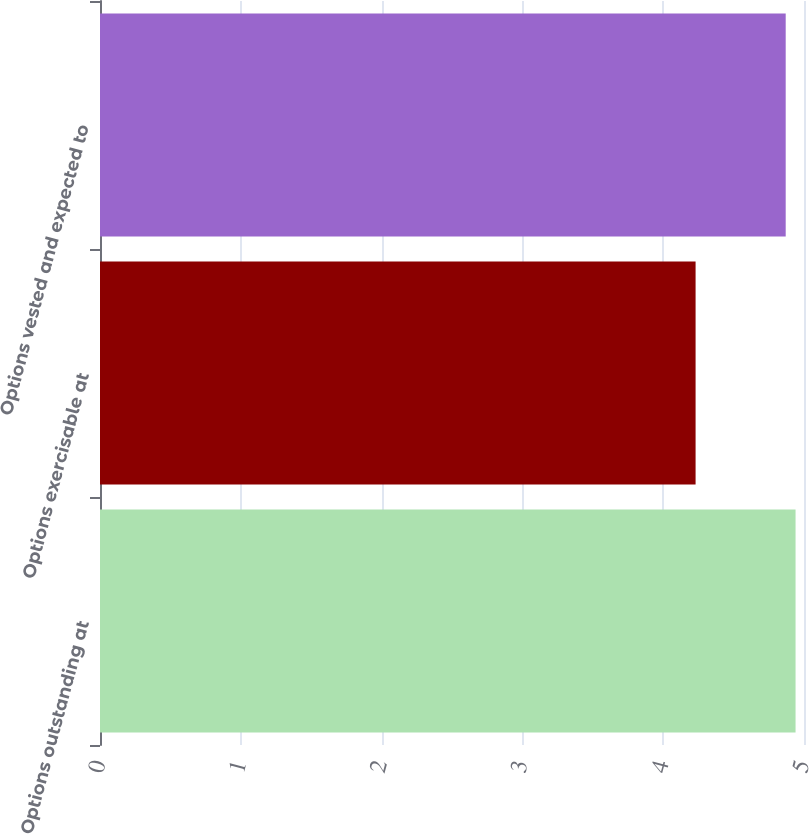Convert chart to OTSL. <chart><loc_0><loc_0><loc_500><loc_500><bar_chart><fcel>Options outstanding at<fcel>Options exercisable at<fcel>Options vested and expected to<nl><fcel>4.94<fcel>4.23<fcel>4.87<nl></chart> 